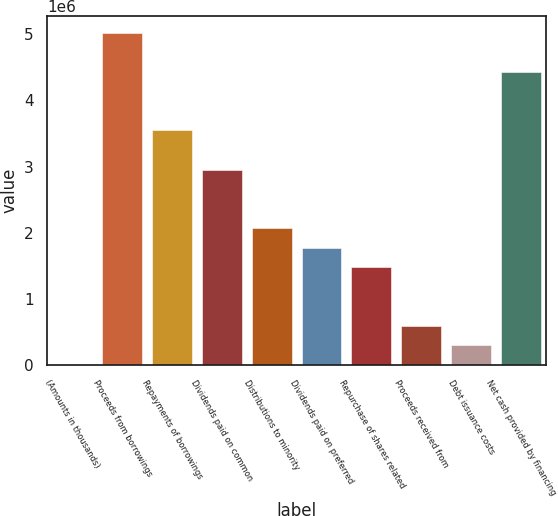<chart> <loc_0><loc_0><loc_500><loc_500><bar_chart><fcel>(Amounts in thousands)<fcel>Proceeds from borrowings<fcel>Repayments of borrowings<fcel>Dividends paid on common<fcel>Distributions to minority<fcel>Dividends paid on preferred<fcel>Repurchase of shares related<fcel>Proceeds received from<fcel>Debt issuance costs<fcel>Net cash provided by financing<nl><fcel>2007<fcel>5.02124e+06<fcel>3.545e+06<fcel>2.9545e+06<fcel>2.06875e+06<fcel>1.7735e+06<fcel>1.47825e+06<fcel>592505<fcel>297256<fcel>4.43074e+06<nl></chart> 